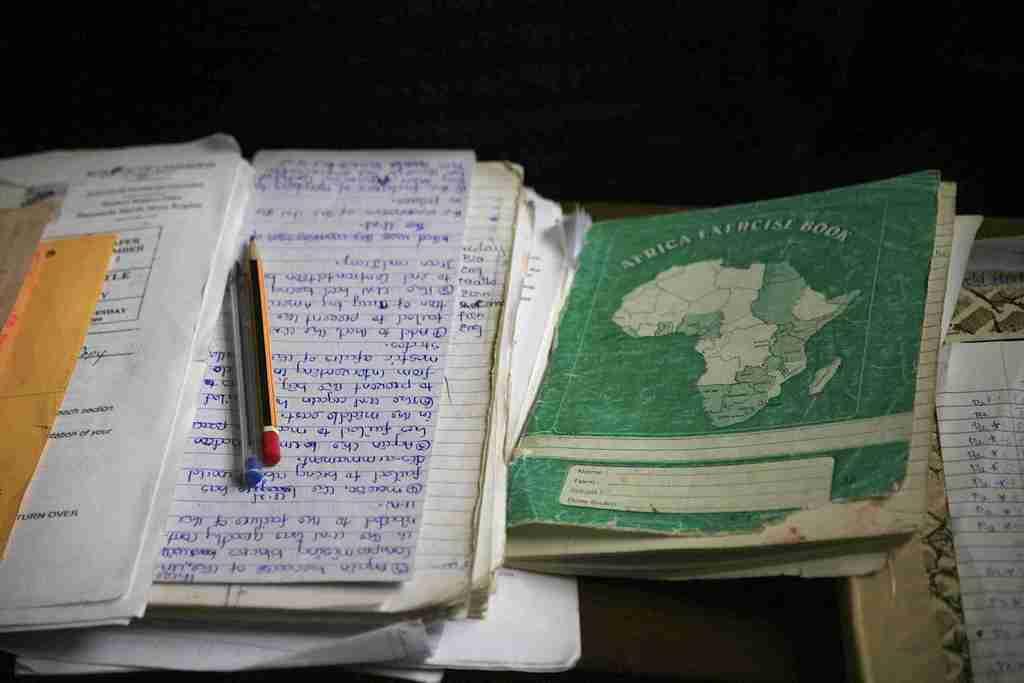What country is the green book about?
Make the answer very short. Africa. 